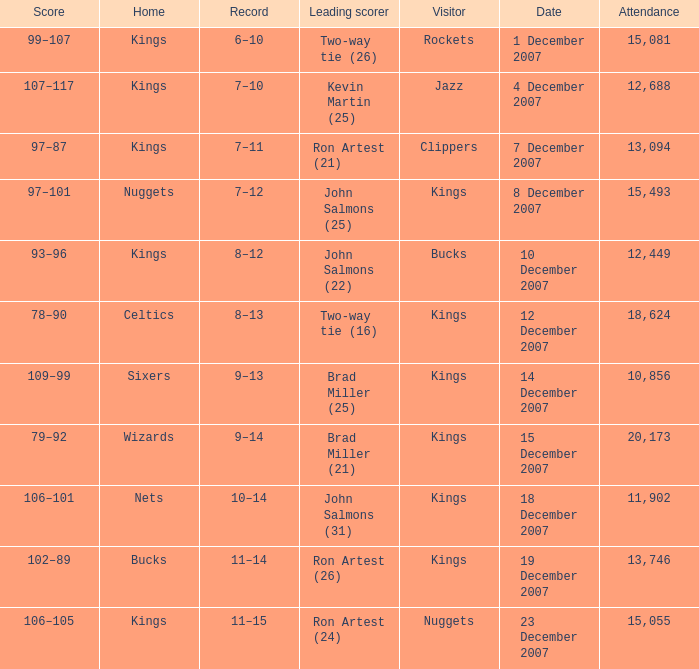What was the record of the game where the Rockets were the visiting team? 6–10. 